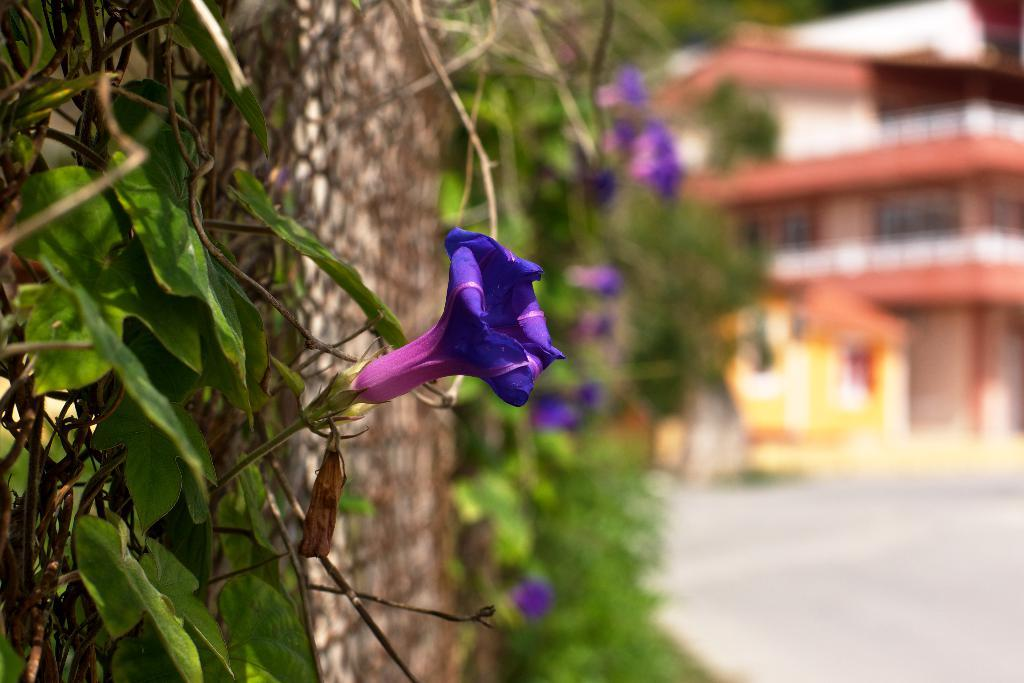What type of plants are visible in the image? There are plants with flowers in the image. What can be seen in the background of the image? There is a building in the background of the image. What type of ornament is placed on the partner's grave in the image? There is no cemetery, ornament, or partner present in the image. The image features plants with flowers and a building in the background. 